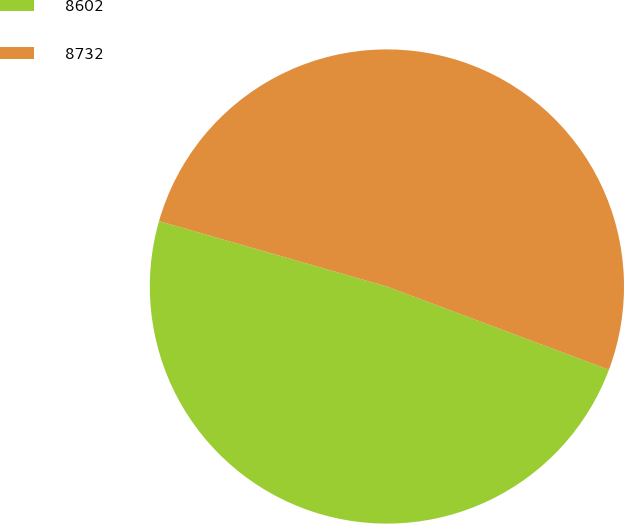Convert chart. <chart><loc_0><loc_0><loc_500><loc_500><pie_chart><fcel>8602<fcel>8732<nl><fcel>48.74%<fcel>51.26%<nl></chart> 